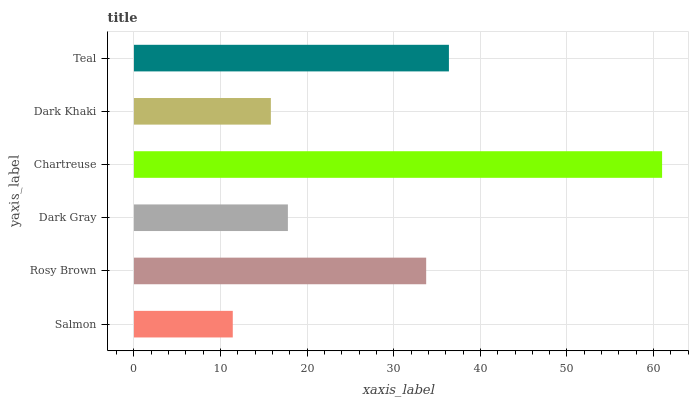Is Salmon the minimum?
Answer yes or no. Yes. Is Chartreuse the maximum?
Answer yes or no. Yes. Is Rosy Brown the minimum?
Answer yes or no. No. Is Rosy Brown the maximum?
Answer yes or no. No. Is Rosy Brown greater than Salmon?
Answer yes or no. Yes. Is Salmon less than Rosy Brown?
Answer yes or no. Yes. Is Salmon greater than Rosy Brown?
Answer yes or no. No. Is Rosy Brown less than Salmon?
Answer yes or no. No. Is Rosy Brown the high median?
Answer yes or no. Yes. Is Dark Gray the low median?
Answer yes or no. Yes. Is Chartreuse the high median?
Answer yes or no. No. Is Salmon the low median?
Answer yes or no. No. 